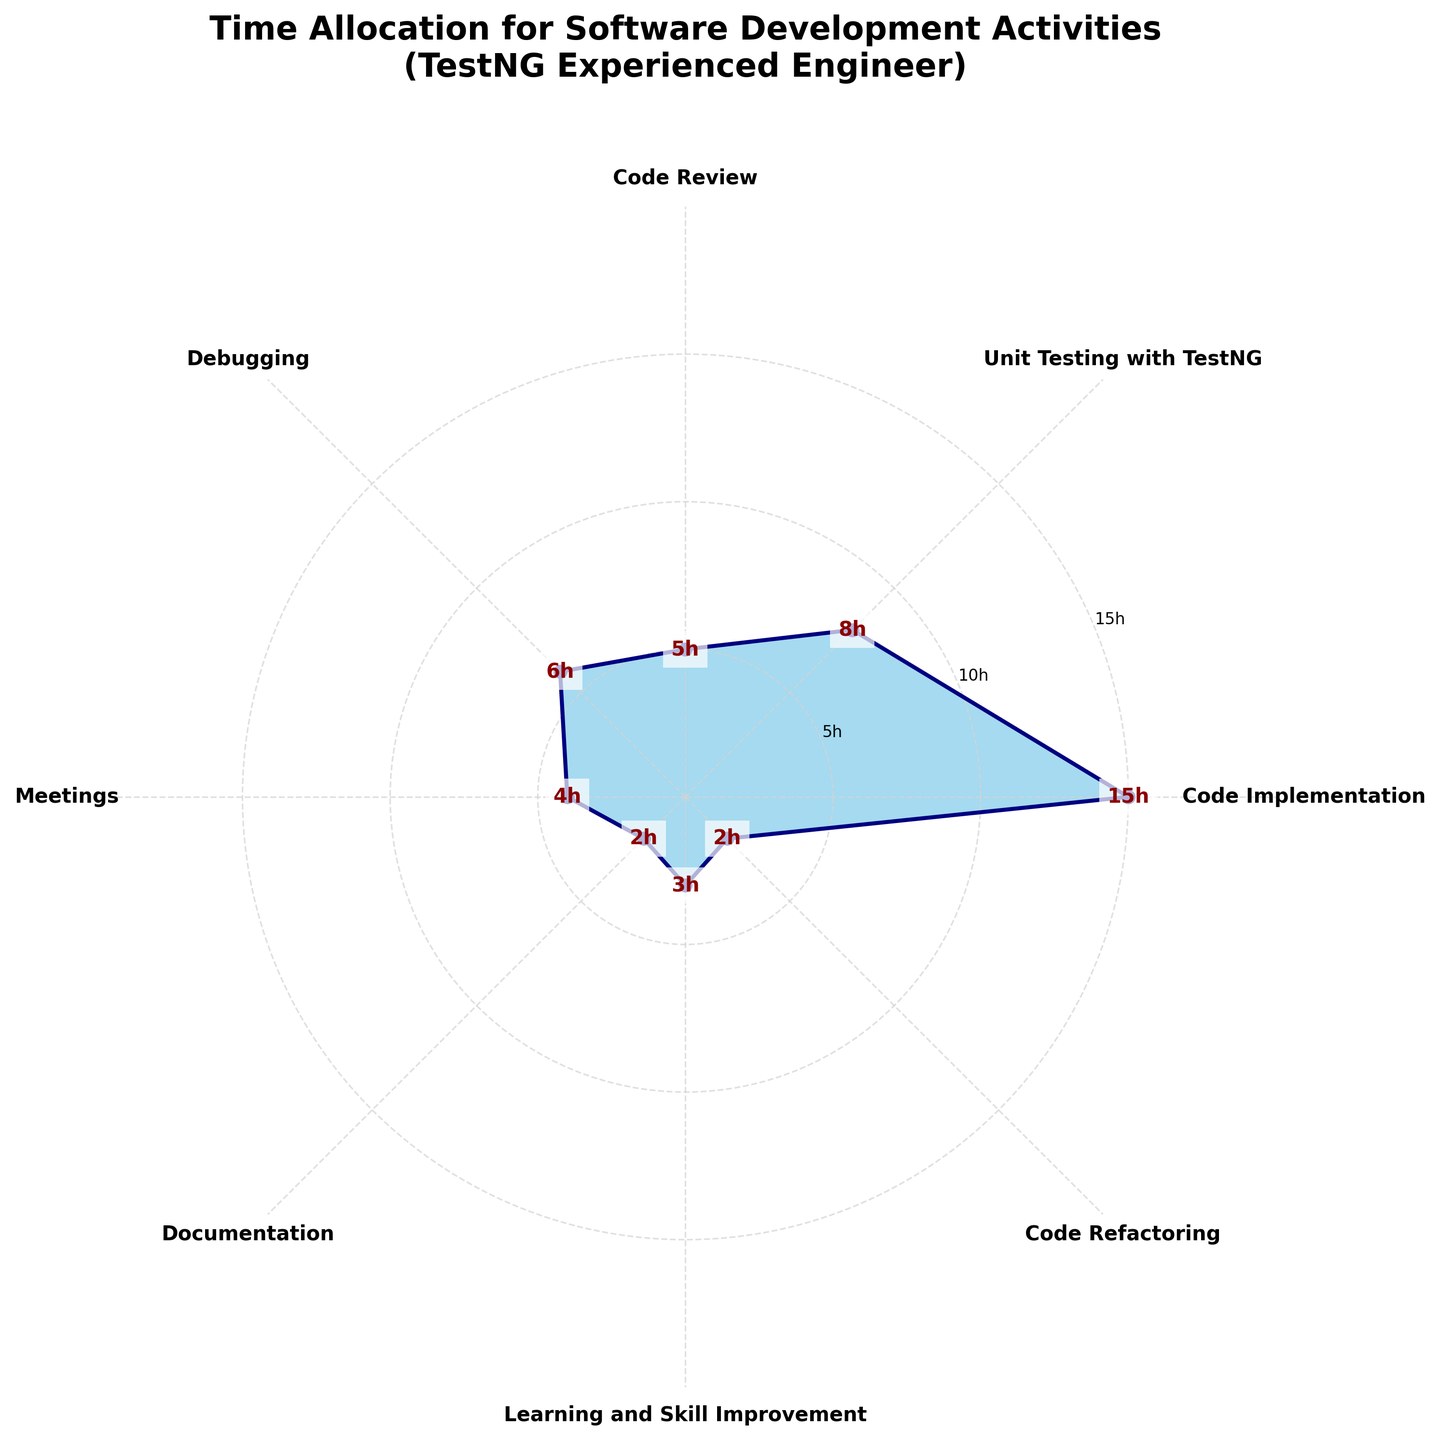What's the highest number of hours spent on any activity? Identify the segment with the highest value by looking at the radial extension. "Code Implementation" extends the furthest with 15 hours.
Answer: 15 hours What's the total number of hours spent on activities in a week? Add the hours spent on each activity: 15 (Code Implementation) + 8 (Unit Testing with TestNG) + 5 (Code Review) + 6 (Debugging) + 4 (Meetings) + 2 (Documentation) + 3 (Learning and Skill Improvement) + 2 (Code Refactoring) = 45 hours.
Answer: 45 hours Which activity takes more time, Unit Testing with TestNG or Debugging? Compare the heights of the corresponding segments. Unit Testing with TestNG has 8 hours and Debugging has 6 hours.
Answer: Unit Testing with TestNG How does the time spent on Learning and Skill Improvement compare to Code Refactoring? Compare the heights of the segments. Learning and Skill Improvement has 3 hours, whereas Code Refactoring has 2 hours.
Answer: More time is spent on Learning and Skill Improvement Which activities have less than or equal to 4 hours allocated? Identify segments with heights no greater than 4. These are "Meetings" with 4 hours, "Documentation" with 2 hours, and "Code Refactoring" with 2 hours.
Answer: Meetings, Documentation, Code Refactoring How does the time spent on Unit Testing with TestNG relate to the sum of Documentation and Code Refactoring? Calculate the sum of Documentation and Code Refactoring, i.e., 2 + 2 = 4 hours. Compare this to Unit Testing with TestNG, which has 8 hours.
Answer: More time is spent on Unit Testing with TestNG What's the average number of hours spent on the activities? Total hours are 45. There are 8 activities, so the average is 45 / 8 = 5.625 hours.
Answer: 5.625 hours Which activity has the least amount of time allocated? Identify the shortest segment. Both "Documentation" and "Code Refactoring" have the lowest value, 2 hours each.
Answer: Documentation, Code Refactoring What is the difference in hours allocated to Code Implementation and Code Review? Subtract the hours of Code Review from Code Implementation. Code Implementation has 15 hours, and Code Review has 5 hours. 15 - 5 = 10 hours.
Answer: 10 hours What's the ratio of time spent on Meetings to total hours? Total hours is 45. Meetings is 4 hours. Ratio is 4 / 45.
Answer: 4:45 